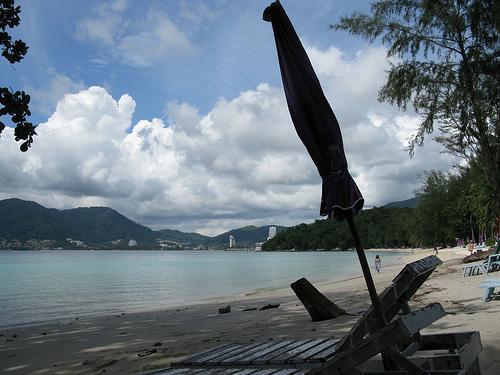How many umbrellas?
Give a very brief answer. 1. 